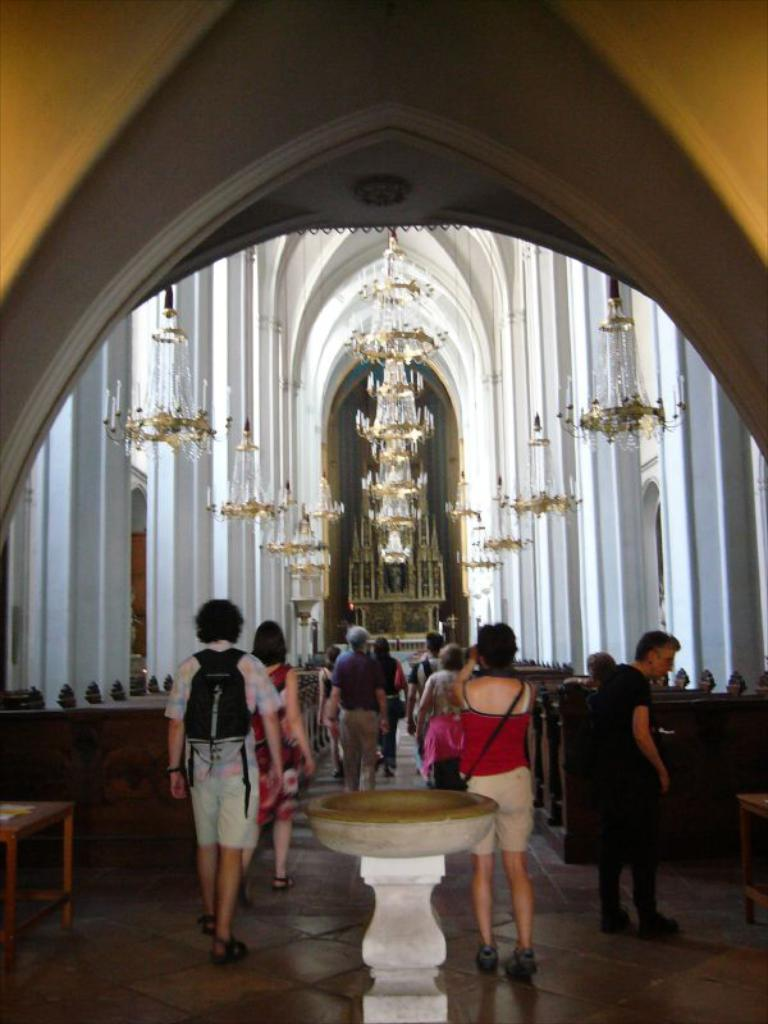What are the people in the image doing? The people in the image are walking. Where are the people walking? The people are walking through an aisle. What can be seen on both sides of the aisle? There are benches on both sides of the aisle. What is visible in the background of the image? There is a building and a chandelier in the background of the image. What type of pancake is being served for dinner in the image? There is no pancake or dinner being served in the image; it features people walking through an aisle with benches on both sides. 